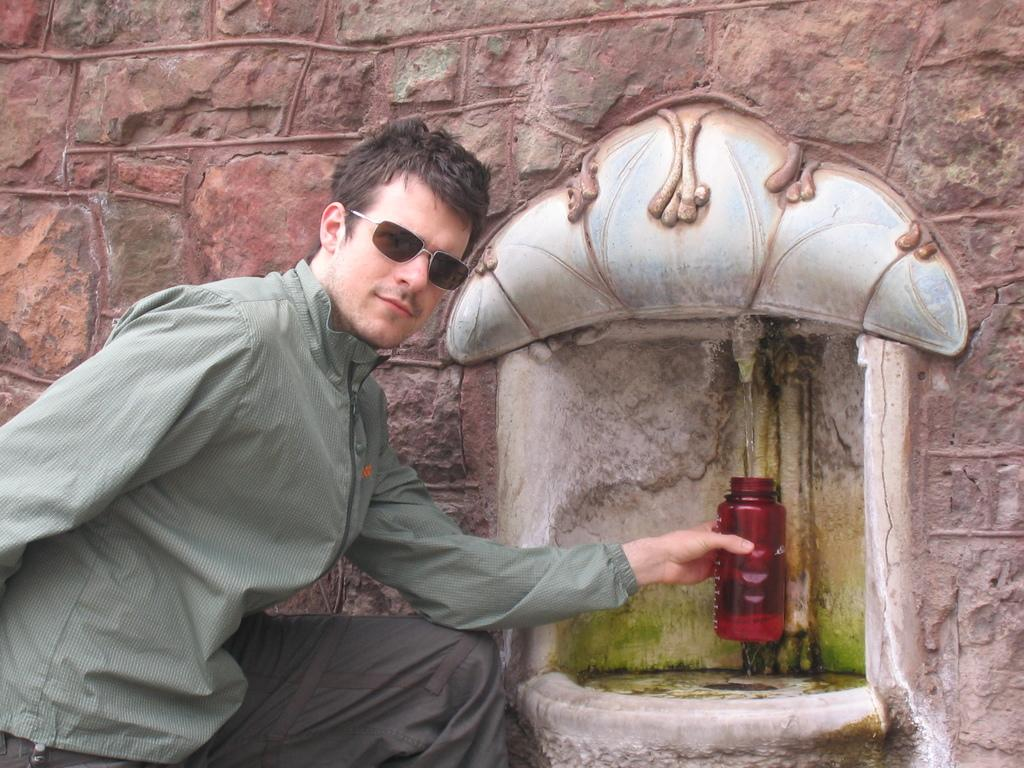What is the person in the image doing? The person is filling water in the bottle. What object is the person holding? The person is holding a bottle. What protective gear is the person wearing? The person is wearing goggles. How is the person feeling in the image? The person is smiling. What can be seen in the background of the image? There is a wall in the background of the image. What is the source of water in the image? There is a tap in the image. What type of mine is visible in the image? There is no mine present in the image. What kind of collar is the person wearing in the image? The person is not wearing a collar in the image. 